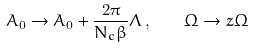Convert formula to latex. <formula><loc_0><loc_0><loc_500><loc_500>A _ { 0 } \rightarrow A _ { 0 } + \frac { 2 \pi } { N _ { c } \beta } \Lambda \, , \quad \Omega \rightarrow z \Omega</formula> 